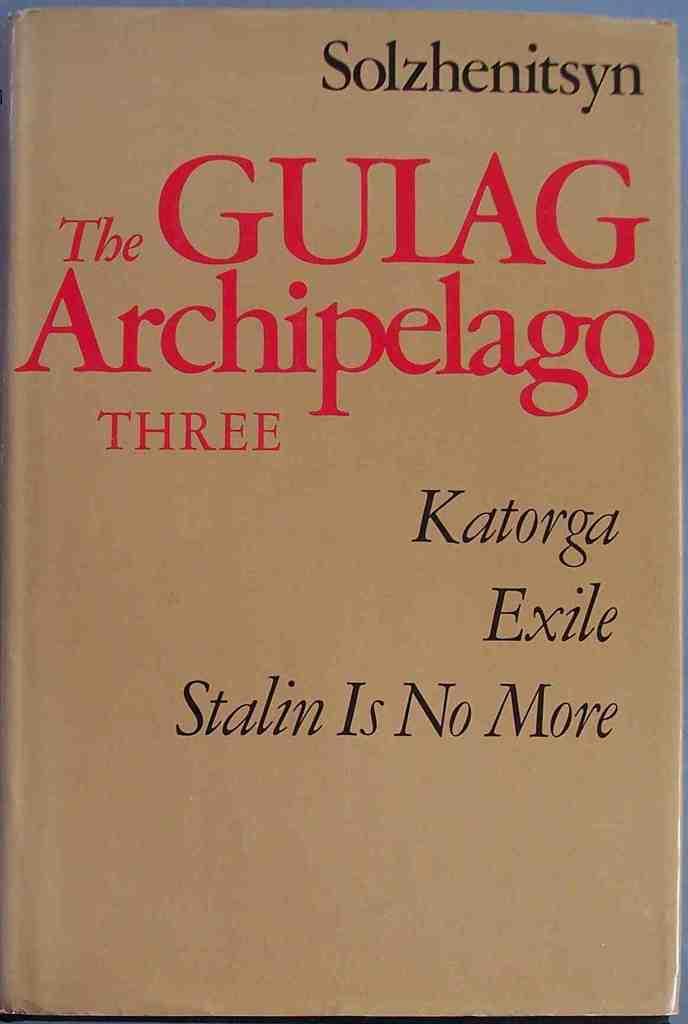Who is the prominent figure that this book mentions?
Offer a very short reply. Stalin. 